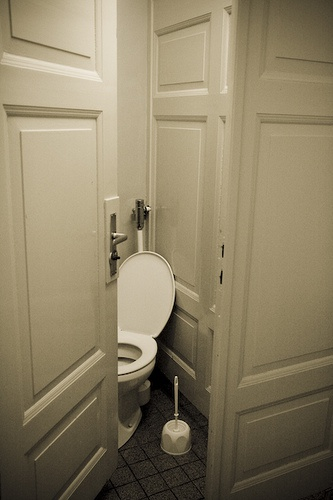Describe the objects in this image and their specific colors. I can see a toilet in gray, tan, and black tones in this image. 